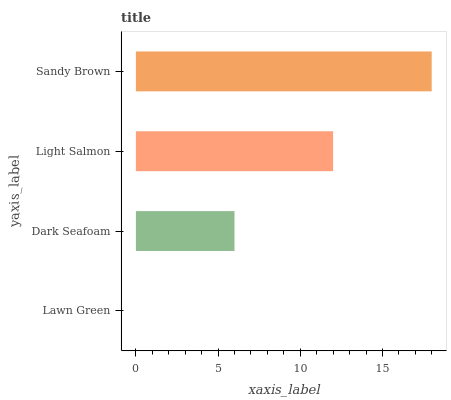Is Lawn Green the minimum?
Answer yes or no. Yes. Is Sandy Brown the maximum?
Answer yes or no. Yes. Is Dark Seafoam the minimum?
Answer yes or no. No. Is Dark Seafoam the maximum?
Answer yes or no. No. Is Dark Seafoam greater than Lawn Green?
Answer yes or no. Yes. Is Lawn Green less than Dark Seafoam?
Answer yes or no. Yes. Is Lawn Green greater than Dark Seafoam?
Answer yes or no. No. Is Dark Seafoam less than Lawn Green?
Answer yes or no. No. Is Light Salmon the high median?
Answer yes or no. Yes. Is Dark Seafoam the low median?
Answer yes or no. Yes. Is Dark Seafoam the high median?
Answer yes or no. No. Is Sandy Brown the low median?
Answer yes or no. No. 